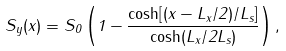<formula> <loc_0><loc_0><loc_500><loc_500>S _ { y } ( x ) = S _ { 0 } \left ( 1 - \frac { \cosh [ ( x - L _ { x } / 2 ) / L _ { s } ] } { \cosh ( L _ { x } / 2 L _ { s } ) } \right ) ,</formula> 